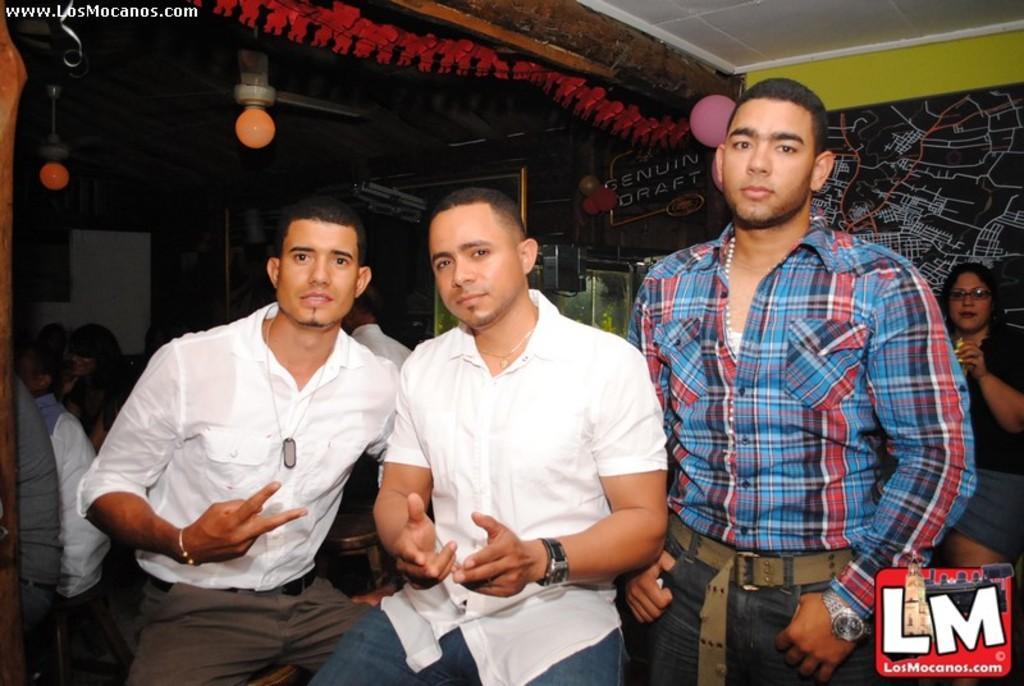In one or two sentences, can you explain what this image depicts? In this pictures we can see three persons in the middle. These two are in the sitting position, and the other one is in standing position. And on the right side of a picture we can see a women. And on the left side we can see some persons are sitting. And on the background there is a wall. And these are the bulbs. 